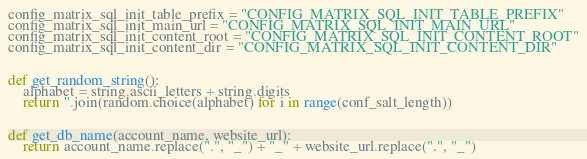Convert code to text. <code><loc_0><loc_0><loc_500><loc_500><_Python_>config_matrix_sql_init_table_prefix = "CONFIG_MATRIX_SQL_INIT_TABLE_PREFIX"
config_matrix_sql_init_main_url = "CONFIG_MATRIX_SQL_INIT_MAIN_URL"
config_matrix_sql_init_content_root = "CONFIG_MATRIX_SQL_INIT_CONTENT_ROOT"
config_matrix_sql_init_content_dir = "CONFIG_MATRIX_SQL_INIT_CONTENT_DIR"


def get_random_string():
    alphabet = string.ascii_letters + string.digits
    return ''.join(random.choice(alphabet) for i in range(conf_salt_length))


def get_db_name(account_name, website_url):
    return account_name.replace(".", "_") + "_" + website_url.replace(".", "_")

</code> 